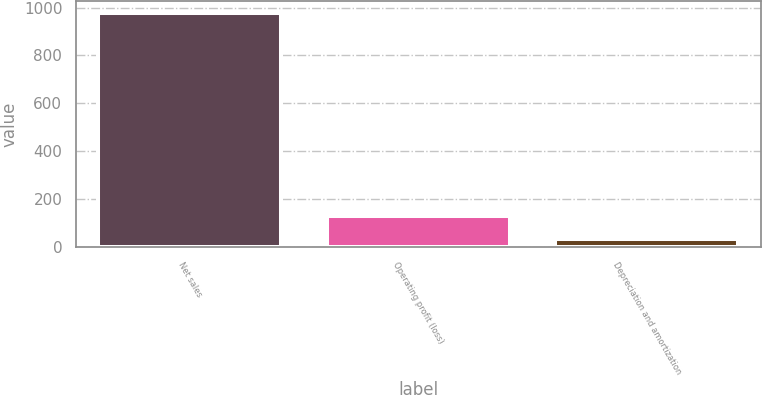<chart> <loc_0><loc_0><loc_500><loc_500><bar_chart><fcel>Net sales<fcel>Operating profit (loss)<fcel>Depreciation and amortization<nl><fcel>979<fcel>128.5<fcel>34<nl></chart> 